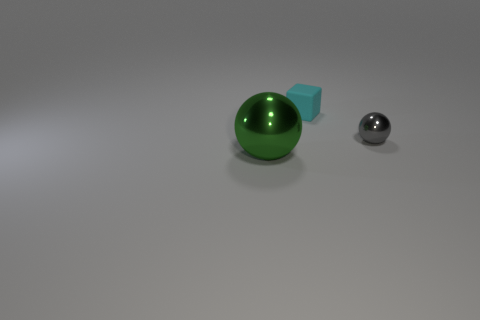Is there a tiny shiny object right of the object behind the small gray ball?
Offer a terse response. Yes. Is there anything else that is the same shape as the green thing?
Offer a very short reply. Yes. Do the rubber object and the green object have the same size?
Give a very brief answer. No. There is a ball on the right side of the thing left of the object behind the tiny gray metallic thing; what is it made of?
Your response must be concise. Metal. Are there an equal number of big green things that are behind the large thing and green shiny things?
Keep it short and to the point. No. Are there any other things that are the same size as the cyan cube?
Your answer should be compact. Yes. How many objects are either spheres or small gray metallic things?
Keep it short and to the point. 2. What shape is the large thing that is made of the same material as the gray ball?
Make the answer very short. Sphere. What size is the metallic thing that is behind the metallic object on the left side of the gray thing?
Your answer should be very brief. Small. What number of large things are rubber blocks or green things?
Offer a terse response. 1. 